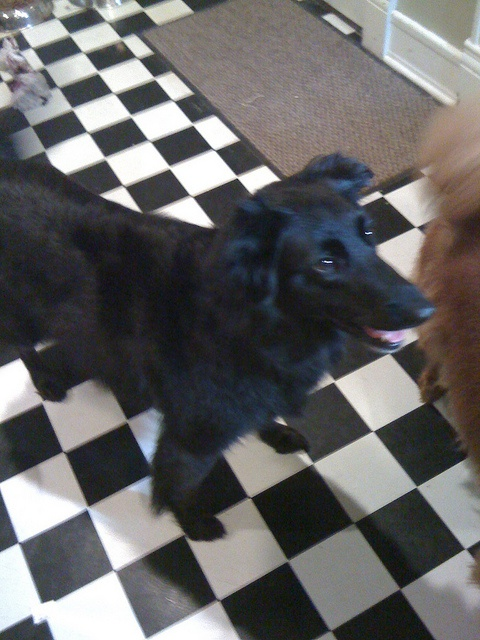Describe the objects in this image and their specific colors. I can see dog in gray, black, and darkblue tones and dog in gray, maroon, and black tones in this image. 